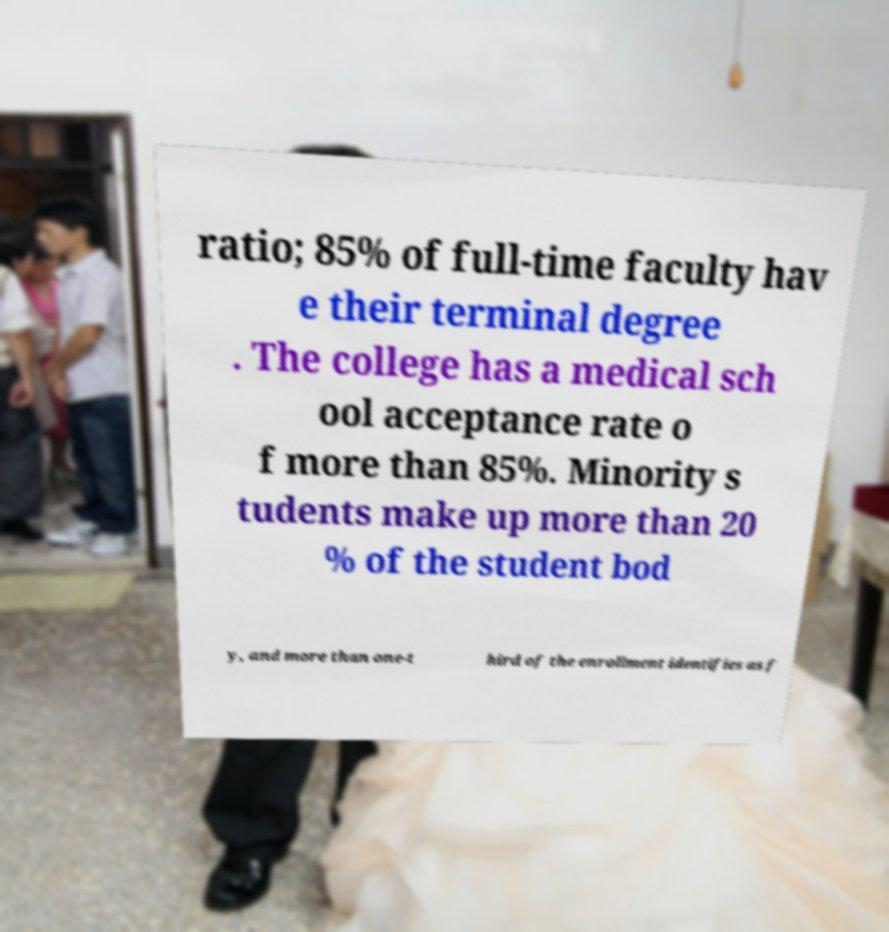There's text embedded in this image that I need extracted. Can you transcribe it verbatim? ratio; 85% of full-time faculty hav e their terminal degree . The college has a medical sch ool acceptance rate o f more than 85%. Minority s tudents make up more than 20 % of the student bod y, and more than one-t hird of the enrollment identifies as f 